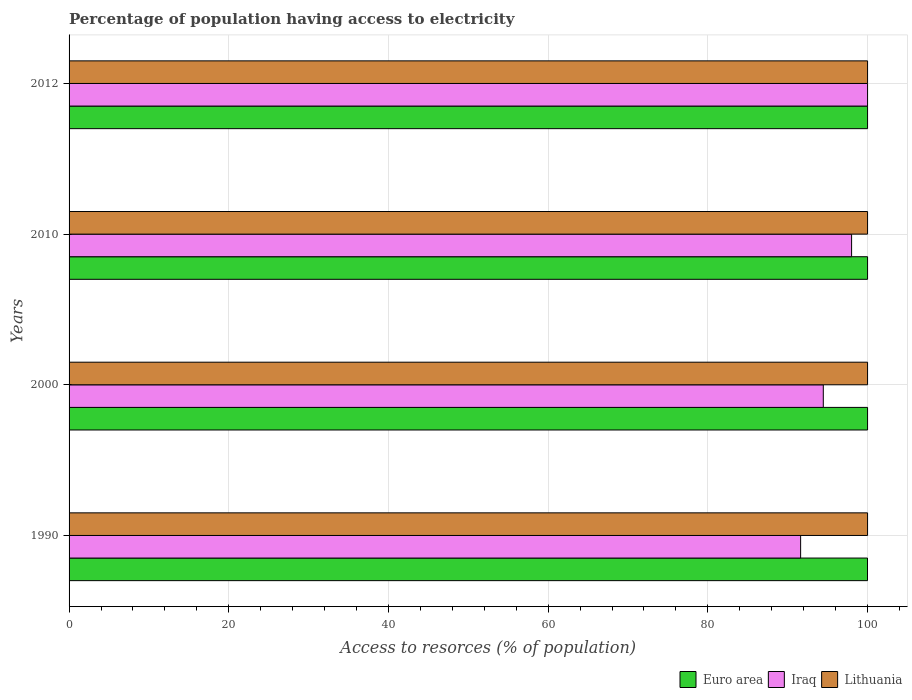How many different coloured bars are there?
Provide a succinct answer. 3. How many groups of bars are there?
Offer a very short reply. 4. Are the number of bars per tick equal to the number of legend labels?
Ensure brevity in your answer.  Yes. How many bars are there on the 4th tick from the bottom?
Your response must be concise. 3. In how many cases, is the number of bars for a given year not equal to the number of legend labels?
Make the answer very short. 0. Across all years, what is the maximum percentage of population having access to electricity in Euro area?
Your answer should be compact. 100. Across all years, what is the minimum percentage of population having access to electricity in Iraq?
Your response must be concise. 91.62. In which year was the percentage of population having access to electricity in Lithuania maximum?
Your response must be concise. 1990. What is the total percentage of population having access to electricity in Iraq in the graph?
Provide a succinct answer. 384.07. What is the difference between the percentage of population having access to electricity in Euro area in 2010 and the percentage of population having access to electricity in Lithuania in 2000?
Ensure brevity in your answer.  0. What is the average percentage of population having access to electricity in Lithuania per year?
Your answer should be very brief. 100. In how many years, is the percentage of population having access to electricity in Iraq greater than 56 %?
Offer a very short reply. 4. Is the difference between the percentage of population having access to electricity in Lithuania in 2010 and 2012 greater than the difference between the percentage of population having access to electricity in Euro area in 2010 and 2012?
Your answer should be very brief. No. What is the difference between the highest and the second highest percentage of population having access to electricity in Lithuania?
Ensure brevity in your answer.  0. What is the difference between the highest and the lowest percentage of population having access to electricity in Iraq?
Make the answer very short. 8.38. In how many years, is the percentage of population having access to electricity in Iraq greater than the average percentage of population having access to electricity in Iraq taken over all years?
Ensure brevity in your answer.  2. What does the 1st bar from the bottom in 2000 represents?
Keep it short and to the point. Euro area. Is it the case that in every year, the sum of the percentage of population having access to electricity in Lithuania and percentage of population having access to electricity in Iraq is greater than the percentage of population having access to electricity in Euro area?
Offer a terse response. Yes. How many bars are there?
Offer a very short reply. 12. How many years are there in the graph?
Offer a terse response. 4. What is the difference between two consecutive major ticks on the X-axis?
Your response must be concise. 20. Does the graph contain any zero values?
Offer a very short reply. No. How many legend labels are there?
Provide a short and direct response. 3. What is the title of the graph?
Your answer should be very brief. Percentage of population having access to electricity. What is the label or title of the X-axis?
Your answer should be compact. Access to resorces (% of population). What is the label or title of the Y-axis?
Offer a very short reply. Years. What is the Access to resorces (% of population) of Euro area in 1990?
Offer a very short reply. 99.99. What is the Access to resorces (% of population) of Iraq in 1990?
Offer a terse response. 91.62. What is the Access to resorces (% of population) in Euro area in 2000?
Offer a terse response. 100. What is the Access to resorces (% of population) of Iraq in 2000?
Keep it short and to the point. 94.46. What is the Access to resorces (% of population) in Lithuania in 2000?
Keep it short and to the point. 100. What is the Access to resorces (% of population) of Euro area in 2012?
Provide a succinct answer. 100. What is the Access to resorces (% of population) in Iraq in 2012?
Ensure brevity in your answer.  100. What is the Access to resorces (% of population) in Lithuania in 2012?
Keep it short and to the point. 100. Across all years, what is the maximum Access to resorces (% of population) of Euro area?
Ensure brevity in your answer.  100. Across all years, what is the minimum Access to resorces (% of population) in Euro area?
Keep it short and to the point. 99.99. Across all years, what is the minimum Access to resorces (% of population) in Iraq?
Your answer should be very brief. 91.62. What is the total Access to resorces (% of population) of Euro area in the graph?
Make the answer very short. 399.99. What is the total Access to resorces (% of population) in Iraq in the graph?
Provide a succinct answer. 384.07. What is the total Access to resorces (% of population) of Lithuania in the graph?
Provide a succinct answer. 400. What is the difference between the Access to resorces (% of population) of Euro area in 1990 and that in 2000?
Provide a succinct answer. -0.01. What is the difference between the Access to resorces (% of population) in Iraq in 1990 and that in 2000?
Offer a terse response. -2.84. What is the difference between the Access to resorces (% of population) of Lithuania in 1990 and that in 2000?
Provide a short and direct response. 0. What is the difference between the Access to resorces (% of population) in Euro area in 1990 and that in 2010?
Provide a succinct answer. -0.01. What is the difference between the Access to resorces (% of population) of Iraq in 1990 and that in 2010?
Offer a terse response. -6.38. What is the difference between the Access to resorces (% of population) in Euro area in 1990 and that in 2012?
Keep it short and to the point. -0.01. What is the difference between the Access to resorces (% of population) of Iraq in 1990 and that in 2012?
Give a very brief answer. -8.38. What is the difference between the Access to resorces (% of population) of Lithuania in 1990 and that in 2012?
Provide a short and direct response. 0. What is the difference between the Access to resorces (% of population) of Iraq in 2000 and that in 2010?
Give a very brief answer. -3.54. What is the difference between the Access to resorces (% of population) of Lithuania in 2000 and that in 2010?
Offer a terse response. 0. What is the difference between the Access to resorces (% of population) in Euro area in 2000 and that in 2012?
Your answer should be compact. 0. What is the difference between the Access to resorces (% of population) in Iraq in 2000 and that in 2012?
Make the answer very short. -5.54. What is the difference between the Access to resorces (% of population) in Euro area in 1990 and the Access to resorces (% of population) in Iraq in 2000?
Offer a terse response. 5.54. What is the difference between the Access to resorces (% of population) of Euro area in 1990 and the Access to resorces (% of population) of Lithuania in 2000?
Keep it short and to the point. -0.01. What is the difference between the Access to resorces (% of population) of Iraq in 1990 and the Access to resorces (% of population) of Lithuania in 2000?
Your response must be concise. -8.38. What is the difference between the Access to resorces (% of population) of Euro area in 1990 and the Access to resorces (% of population) of Iraq in 2010?
Your response must be concise. 1.99. What is the difference between the Access to resorces (% of population) of Euro area in 1990 and the Access to resorces (% of population) of Lithuania in 2010?
Keep it short and to the point. -0.01. What is the difference between the Access to resorces (% of population) in Iraq in 1990 and the Access to resorces (% of population) in Lithuania in 2010?
Your response must be concise. -8.38. What is the difference between the Access to resorces (% of population) in Euro area in 1990 and the Access to resorces (% of population) in Iraq in 2012?
Provide a succinct answer. -0.01. What is the difference between the Access to resorces (% of population) of Euro area in 1990 and the Access to resorces (% of population) of Lithuania in 2012?
Give a very brief answer. -0.01. What is the difference between the Access to resorces (% of population) of Iraq in 1990 and the Access to resorces (% of population) of Lithuania in 2012?
Make the answer very short. -8.38. What is the difference between the Access to resorces (% of population) of Euro area in 2000 and the Access to resorces (% of population) of Iraq in 2010?
Offer a terse response. 2. What is the difference between the Access to resorces (% of population) of Iraq in 2000 and the Access to resorces (% of population) of Lithuania in 2010?
Give a very brief answer. -5.54. What is the difference between the Access to resorces (% of population) in Euro area in 2000 and the Access to resorces (% of population) in Iraq in 2012?
Offer a very short reply. 0. What is the difference between the Access to resorces (% of population) of Euro area in 2000 and the Access to resorces (% of population) of Lithuania in 2012?
Provide a short and direct response. 0. What is the difference between the Access to resorces (% of population) of Iraq in 2000 and the Access to resorces (% of population) of Lithuania in 2012?
Offer a very short reply. -5.54. What is the difference between the Access to resorces (% of population) in Iraq in 2010 and the Access to resorces (% of population) in Lithuania in 2012?
Your answer should be compact. -2. What is the average Access to resorces (% of population) of Euro area per year?
Give a very brief answer. 100. What is the average Access to resorces (% of population) of Iraq per year?
Give a very brief answer. 96.02. In the year 1990, what is the difference between the Access to resorces (% of population) in Euro area and Access to resorces (% of population) in Iraq?
Make the answer very short. 8.38. In the year 1990, what is the difference between the Access to resorces (% of population) in Euro area and Access to resorces (% of population) in Lithuania?
Give a very brief answer. -0.01. In the year 1990, what is the difference between the Access to resorces (% of population) in Iraq and Access to resorces (% of population) in Lithuania?
Offer a very short reply. -8.38. In the year 2000, what is the difference between the Access to resorces (% of population) in Euro area and Access to resorces (% of population) in Iraq?
Provide a short and direct response. 5.54. In the year 2000, what is the difference between the Access to resorces (% of population) in Euro area and Access to resorces (% of population) in Lithuania?
Your answer should be compact. 0. In the year 2000, what is the difference between the Access to resorces (% of population) of Iraq and Access to resorces (% of population) of Lithuania?
Your response must be concise. -5.54. In the year 2010, what is the difference between the Access to resorces (% of population) of Euro area and Access to resorces (% of population) of Lithuania?
Offer a very short reply. 0. In the year 2010, what is the difference between the Access to resorces (% of population) of Iraq and Access to resorces (% of population) of Lithuania?
Keep it short and to the point. -2. In the year 2012, what is the difference between the Access to resorces (% of population) in Euro area and Access to resorces (% of population) in Lithuania?
Give a very brief answer. 0. In the year 2012, what is the difference between the Access to resorces (% of population) in Iraq and Access to resorces (% of population) in Lithuania?
Your answer should be very brief. 0. What is the ratio of the Access to resorces (% of population) in Euro area in 1990 to that in 2000?
Make the answer very short. 1. What is the ratio of the Access to resorces (% of population) of Iraq in 1990 to that in 2000?
Offer a very short reply. 0.97. What is the ratio of the Access to resorces (% of population) of Lithuania in 1990 to that in 2000?
Keep it short and to the point. 1. What is the ratio of the Access to resorces (% of population) in Euro area in 1990 to that in 2010?
Make the answer very short. 1. What is the ratio of the Access to resorces (% of population) in Iraq in 1990 to that in 2010?
Your response must be concise. 0.93. What is the ratio of the Access to resorces (% of population) in Lithuania in 1990 to that in 2010?
Keep it short and to the point. 1. What is the ratio of the Access to resorces (% of population) of Iraq in 1990 to that in 2012?
Ensure brevity in your answer.  0.92. What is the ratio of the Access to resorces (% of population) in Lithuania in 1990 to that in 2012?
Provide a short and direct response. 1. What is the ratio of the Access to resorces (% of population) in Euro area in 2000 to that in 2010?
Your answer should be very brief. 1. What is the ratio of the Access to resorces (% of population) of Iraq in 2000 to that in 2010?
Your response must be concise. 0.96. What is the ratio of the Access to resorces (% of population) in Lithuania in 2000 to that in 2010?
Make the answer very short. 1. What is the ratio of the Access to resorces (% of population) in Iraq in 2000 to that in 2012?
Give a very brief answer. 0.94. What is the ratio of the Access to resorces (% of population) in Lithuania in 2010 to that in 2012?
Offer a very short reply. 1. What is the difference between the highest and the second highest Access to resorces (% of population) in Euro area?
Provide a short and direct response. 0. What is the difference between the highest and the second highest Access to resorces (% of population) of Iraq?
Ensure brevity in your answer.  2. What is the difference between the highest and the lowest Access to resorces (% of population) in Euro area?
Offer a very short reply. 0.01. What is the difference between the highest and the lowest Access to resorces (% of population) in Iraq?
Offer a terse response. 8.38. 